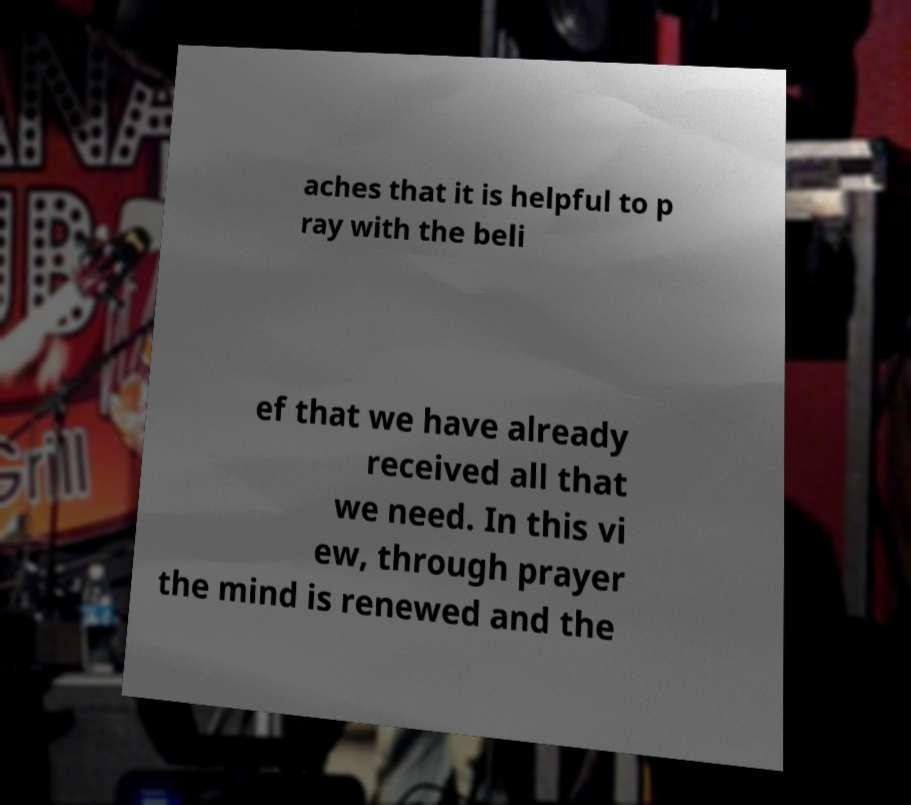Could you extract and type out the text from this image? aches that it is helpful to p ray with the beli ef that we have already received all that we need. In this vi ew, through prayer the mind is renewed and the 